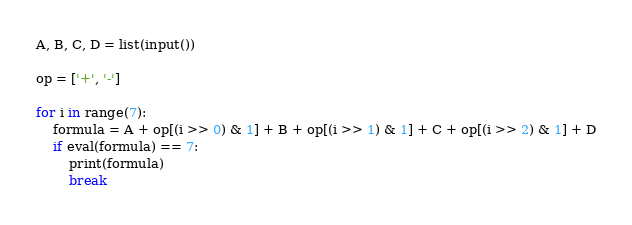<code> <loc_0><loc_0><loc_500><loc_500><_Python_>A, B, C, D = list(input())

op = ['+', '-']

for i in range(7):
    formula = A + op[(i >> 0) & 1] + B + op[(i >> 1) & 1] + C + op[(i >> 2) & 1] + D
    if eval(formula) == 7:
        print(formula)
        break</code> 